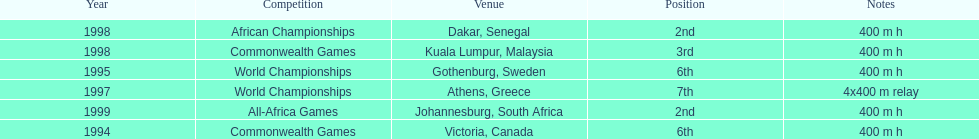Where was the next venue after athens, greece? Kuala Lumpur, Malaysia. 